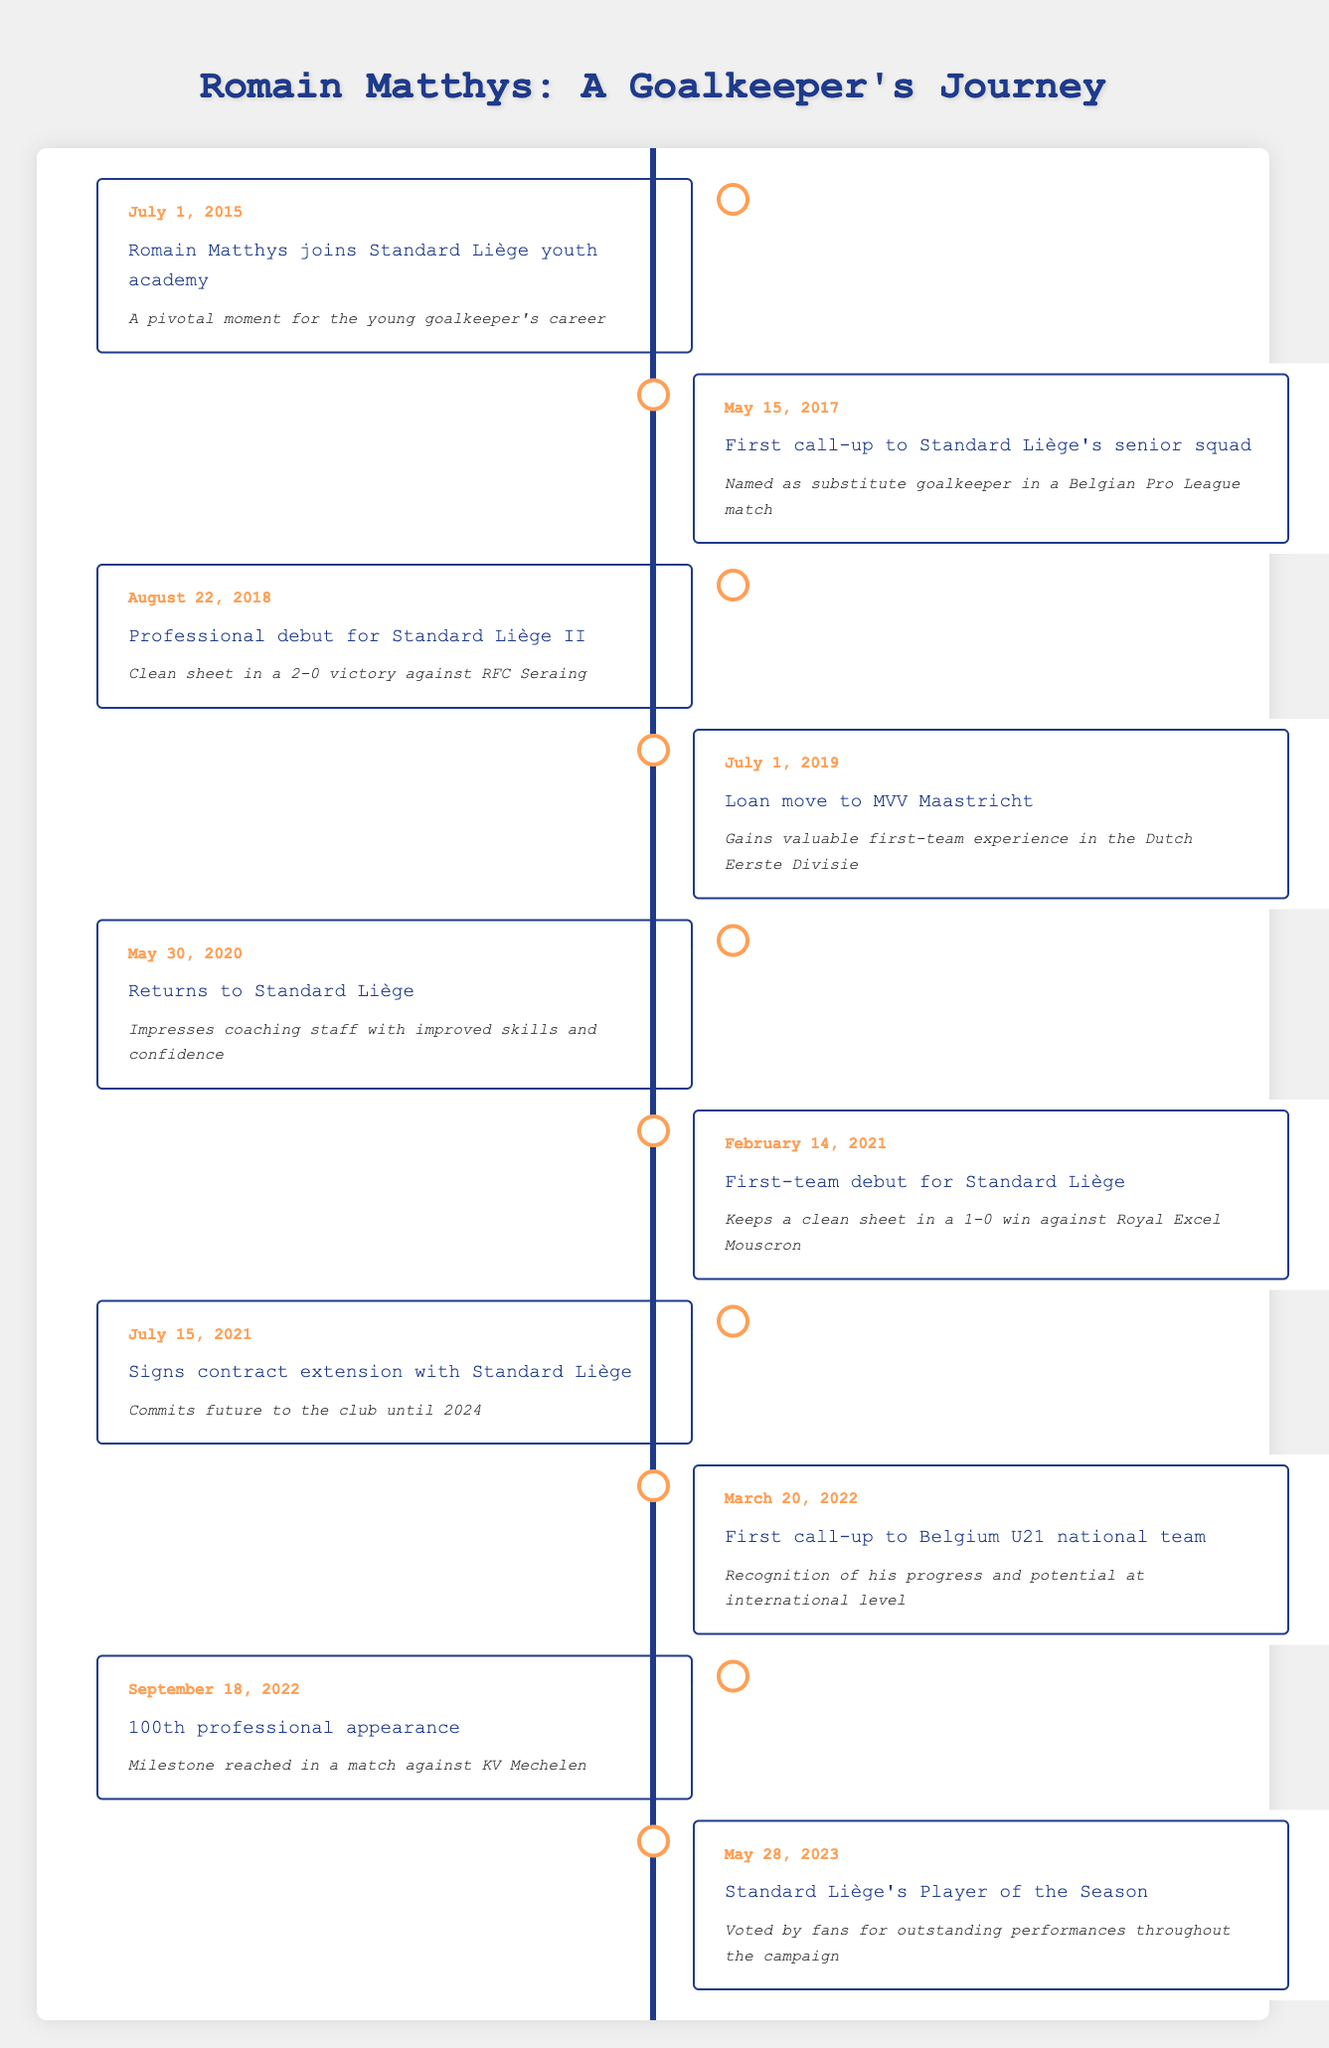What year did Romain Matthys make his first-team debut for Standard Liège? The first-team debut for Romain Matthys is listed as taking place on February 14, 2021. This can be located in the row that talks about his first-team debut, which indicates the date and describes the event.
Answer: 2021 How many professional appearances did Romain Matthys have when he reached his 100th match? The table provides a specific entry stating that he reached his 100th professional appearance on September 18, 2022, signifying that before this date, he had 99 appearances and afterward he reached the milestone of 100.
Answer: 100 Did Romain Matthys return to Standard Liège after his loan to MVV Maastricht? According to the timeline, the entry for May 30, 2020, states that he returned to Standard Liège after his loan period, confirming that he indeed returned to the club.
Answer: Yes How many significant milestones or achievements did Romain Matthys achieve between his debut in 2021 and being named Player of the Season in 2023? Between his debut on February 14, 2021, and being named Player of the Season on May 28, 2023, there are three significant milestones: signing a contract extension on July 15, 2021, receiving a U21 call-up on March 20, 2022, and reaching his 100th appearance on September 18, 2022. Summing these gives a total of three milestones.
Answer: 3 What was one of the notable accomplishments Romain Matthys achieved during his loan to MVV Maastricht? During his loan move to MVV Maastricht starting July 1, 2019, the description indicates that he gained valuable first-team experience in the Dutch Eerste Divisie, which was significant for his development as a player.
Answer: Gained valuable first-team experience 